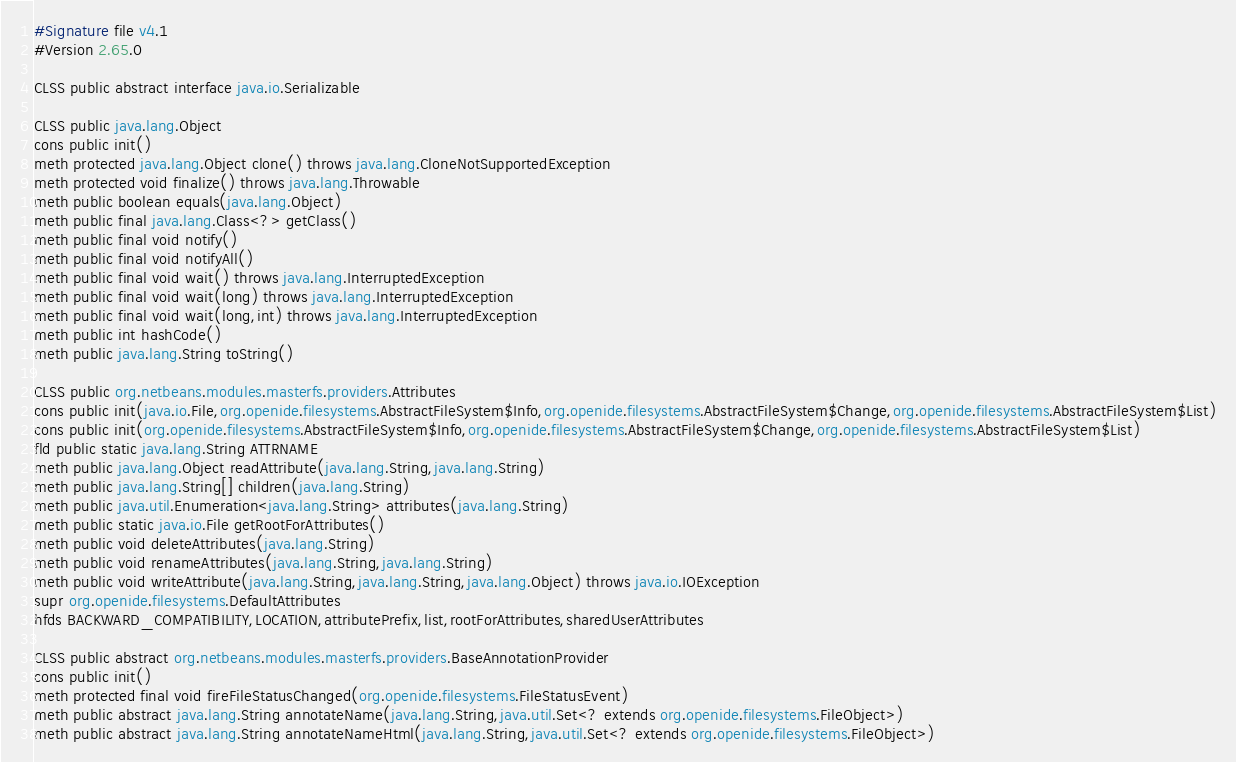Convert code to text. <code><loc_0><loc_0><loc_500><loc_500><_SML_>#Signature file v4.1
#Version 2.65.0

CLSS public abstract interface java.io.Serializable

CLSS public java.lang.Object
cons public init()
meth protected java.lang.Object clone() throws java.lang.CloneNotSupportedException
meth protected void finalize() throws java.lang.Throwable
meth public boolean equals(java.lang.Object)
meth public final java.lang.Class<?> getClass()
meth public final void notify()
meth public final void notifyAll()
meth public final void wait() throws java.lang.InterruptedException
meth public final void wait(long) throws java.lang.InterruptedException
meth public final void wait(long,int) throws java.lang.InterruptedException
meth public int hashCode()
meth public java.lang.String toString()

CLSS public org.netbeans.modules.masterfs.providers.Attributes
cons public init(java.io.File,org.openide.filesystems.AbstractFileSystem$Info,org.openide.filesystems.AbstractFileSystem$Change,org.openide.filesystems.AbstractFileSystem$List)
cons public init(org.openide.filesystems.AbstractFileSystem$Info,org.openide.filesystems.AbstractFileSystem$Change,org.openide.filesystems.AbstractFileSystem$List)
fld public static java.lang.String ATTRNAME
meth public java.lang.Object readAttribute(java.lang.String,java.lang.String)
meth public java.lang.String[] children(java.lang.String)
meth public java.util.Enumeration<java.lang.String> attributes(java.lang.String)
meth public static java.io.File getRootForAttributes()
meth public void deleteAttributes(java.lang.String)
meth public void renameAttributes(java.lang.String,java.lang.String)
meth public void writeAttribute(java.lang.String,java.lang.String,java.lang.Object) throws java.io.IOException
supr org.openide.filesystems.DefaultAttributes
hfds BACKWARD_COMPATIBILITY,LOCATION,attributePrefix,list,rootForAttributes,sharedUserAttributes

CLSS public abstract org.netbeans.modules.masterfs.providers.BaseAnnotationProvider
cons public init()
meth protected final void fireFileStatusChanged(org.openide.filesystems.FileStatusEvent)
meth public abstract java.lang.String annotateName(java.lang.String,java.util.Set<? extends org.openide.filesystems.FileObject>)
meth public abstract java.lang.String annotateNameHtml(java.lang.String,java.util.Set<? extends org.openide.filesystems.FileObject>)</code> 